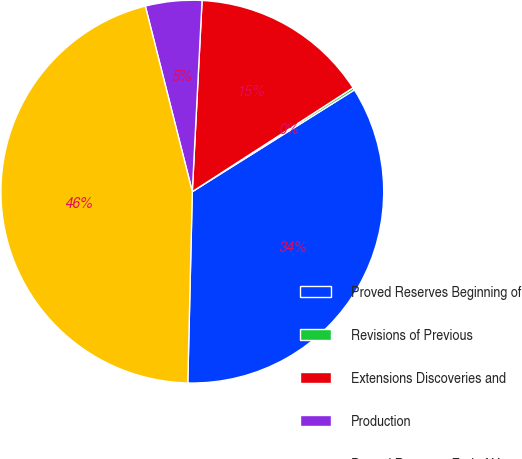Convert chart. <chart><loc_0><loc_0><loc_500><loc_500><pie_chart><fcel>Proved Reserves Beginning of<fcel>Revisions of Previous<fcel>Extensions Discoveries and<fcel>Production<fcel>Proved Reserves End of Year<nl><fcel>34.3%<fcel>0.21%<fcel>15.06%<fcel>4.76%<fcel>45.68%<nl></chart> 